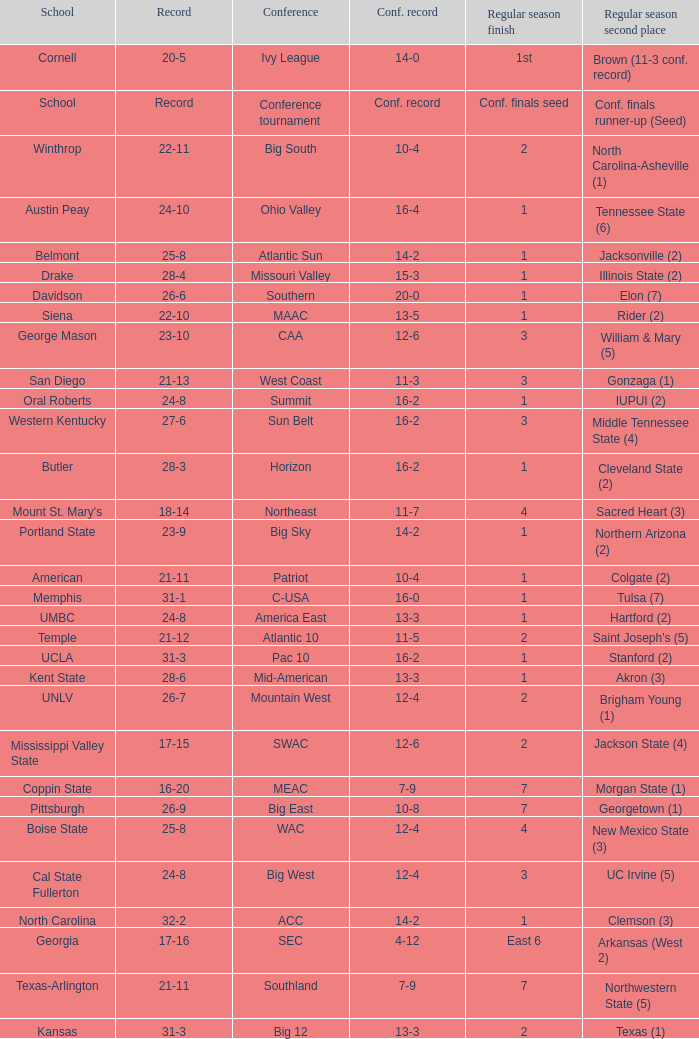What was the comprehensive record for oral roberts college? 24-8. 